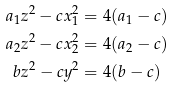<formula> <loc_0><loc_0><loc_500><loc_500>a _ { 1 } z ^ { 2 } - c x _ { 1 } ^ { 2 } & = 4 ( a _ { 1 } - c ) \\ a _ { 2 } z ^ { 2 } - c x _ { 2 } ^ { 2 } & = 4 ( a _ { 2 } - c ) \\ b z ^ { 2 } - c y ^ { 2 } & = 4 ( b - c )</formula> 